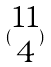<formula> <loc_0><loc_0><loc_500><loc_500>( \begin{matrix} 1 1 \\ 4 \end{matrix} )</formula> 